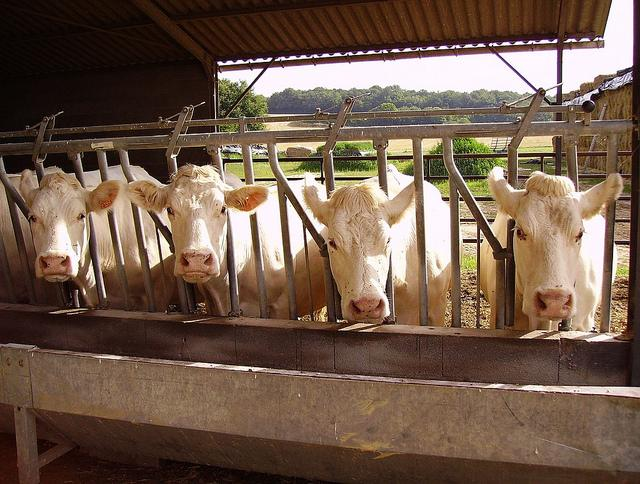Why are these cows held in place at the feeder? to eat 